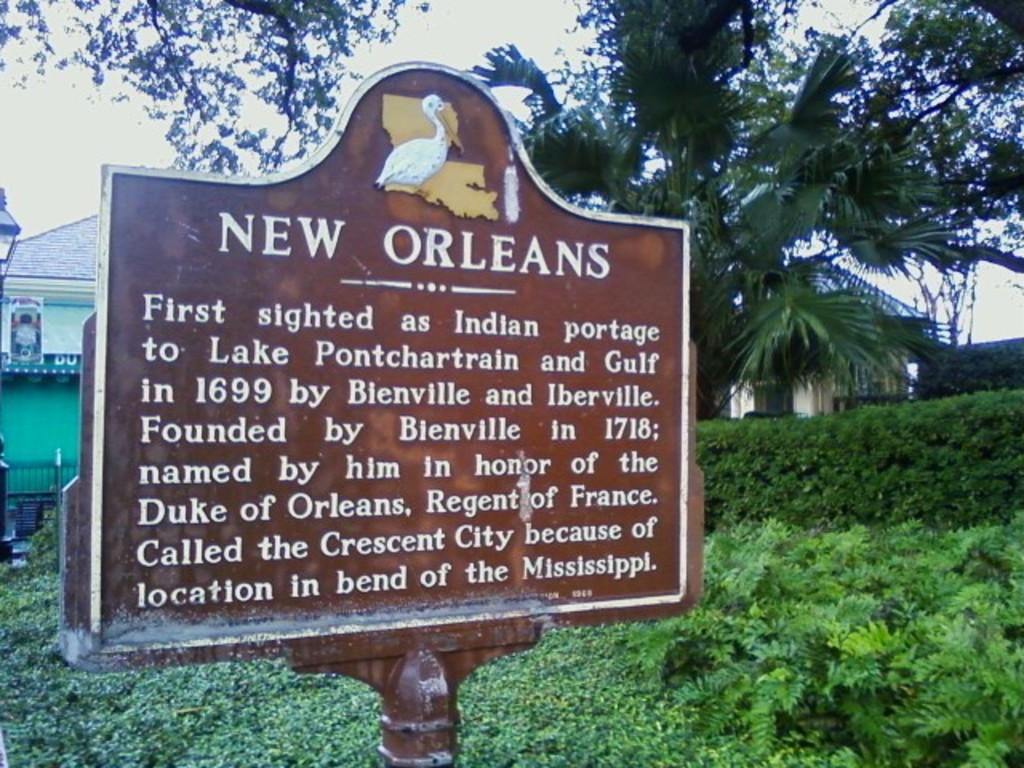What is the main object in the foreground of the image? There is a board in brown color in the image. What can be seen in the background of the image? There are small plants and trees, as well as a house, in the background of the image. What is visible at the top of the image? The sky is visible at the top of the image. Where is the sink located in the image? There is no sink present in the image. Can you see a guitar being played in the image? There is no guitar or any musical instrument being played in the image. 